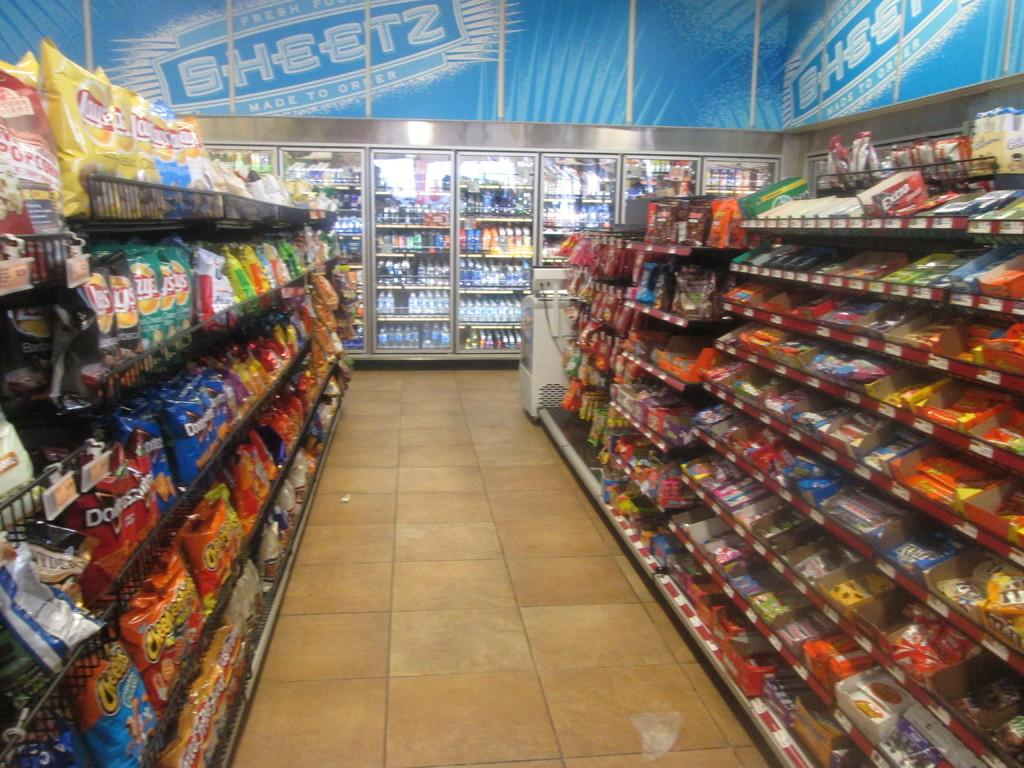Provide a one-sentence caption for the provided image. Sheets banner on top of fridge and bags of Doritos and Cheetos chips on shelf. 